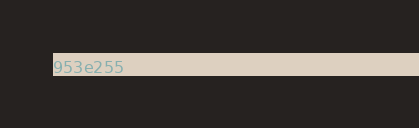<code> <loc_0><loc_0><loc_500><loc_500><_SML_>953e255cb65df378cf98371ead748160</code> 